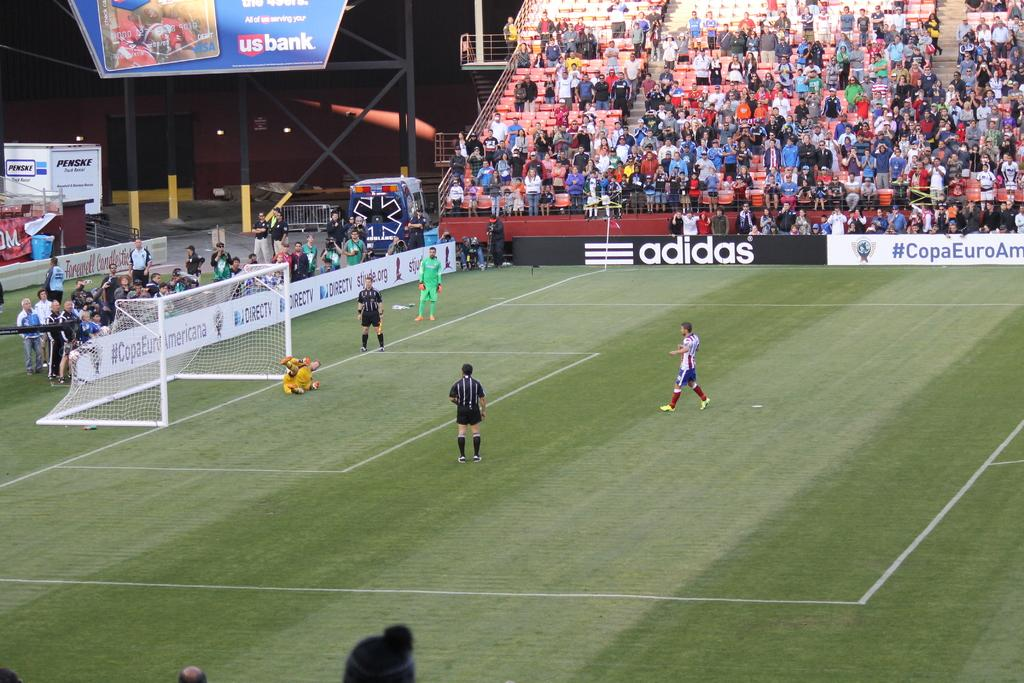<image>
Relay a brief, clear account of the picture shown. Men play soccer near an ad for adidas. 